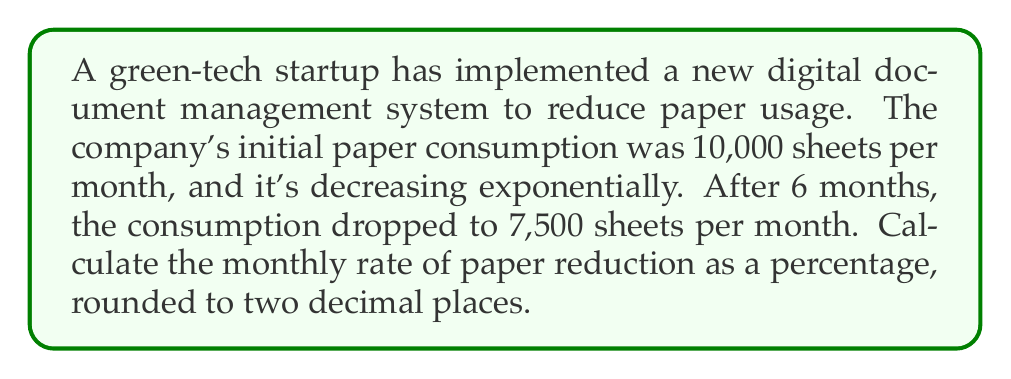Provide a solution to this math problem. To solve this problem, we'll use the exponential decay formula:

$$A(t) = A_0 \cdot e^{-rt}$$

Where:
$A(t)$ is the amount at time $t$
$A_0$ is the initial amount
$r$ is the decay rate
$t$ is the time

Given:
$A_0 = 10,000$ sheets
$A(6) = 7,500$ sheets
$t = 6$ months

Step 1: Substitute the values into the exponential decay formula:
$$7,500 = 10,000 \cdot e^{-6r}$$

Step 2: Divide both sides by 10,000:
$$0.75 = e^{-6r}$$

Step 3: Take the natural logarithm of both sides:
$$\ln(0.75) = -6r$$

Step 4: Solve for $r$:
$$r = -\frac{\ln(0.75)}{6}$$

Step 5: Calculate the value of $r$:
$$r \approx 0.0477$$

Step 6: Convert the rate to a percentage:
$$\text{Percentage rate} = r \cdot 100\% \approx 4.77\%$$

Step 7: Round to two decimal places:
$$\text{Rounded percentage rate} = 4.77\%$$
Answer: 4.77% 